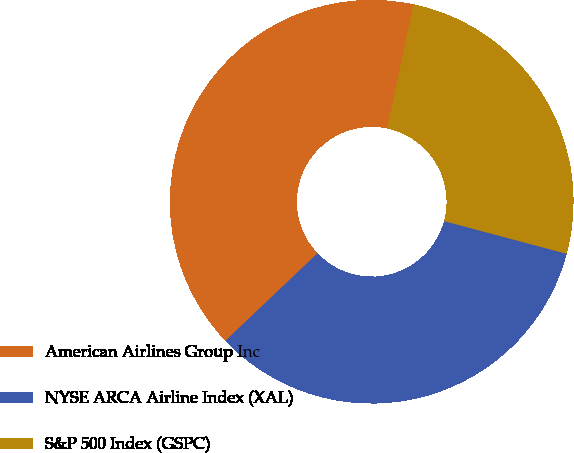Convert chart. <chart><loc_0><loc_0><loc_500><loc_500><pie_chart><fcel>American Airlines Group Inc<fcel>NYSE ARCA Airline Index (XAL)<fcel>S&P 500 Index (GSPC)<nl><fcel>40.42%<fcel>33.75%<fcel>25.83%<nl></chart> 